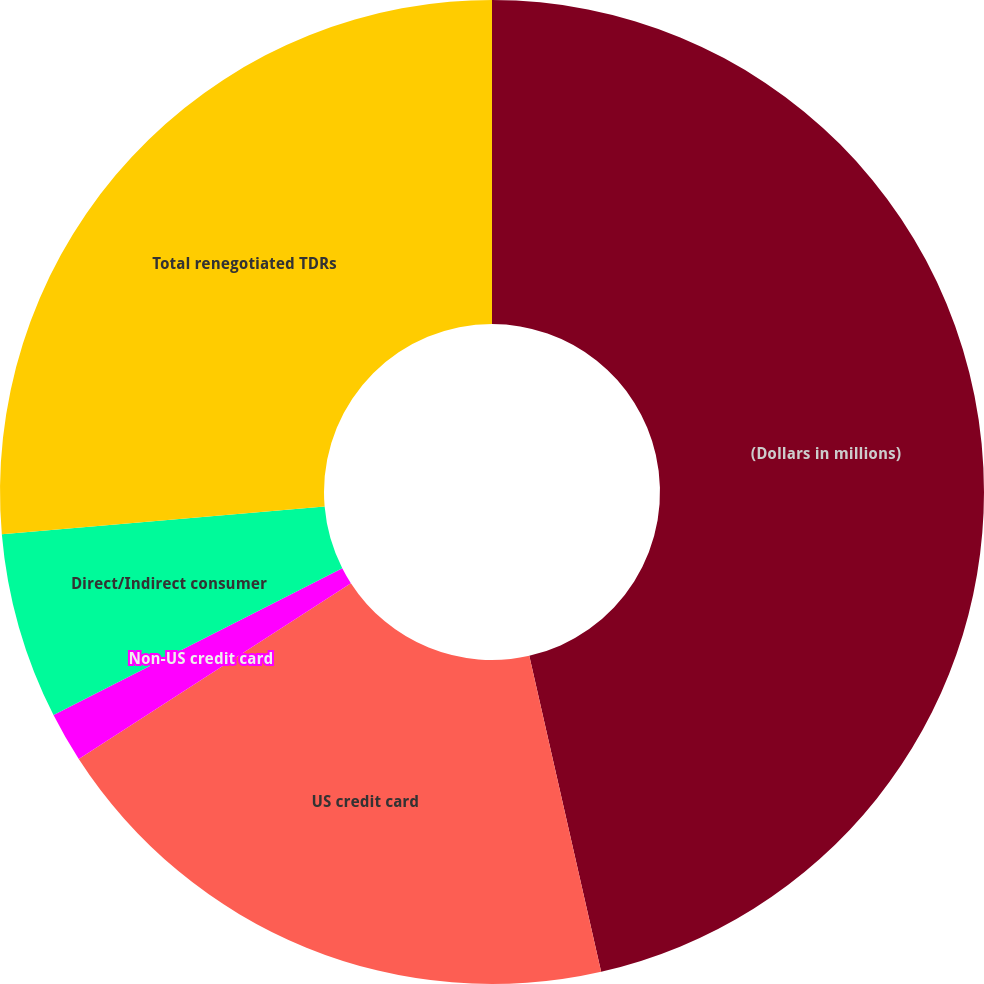Convert chart. <chart><loc_0><loc_0><loc_500><loc_500><pie_chart><fcel>(Dollars in millions)<fcel>US credit card<fcel>Non-US credit card<fcel>Direct/Indirect consumer<fcel>Total renegotiated TDRs<nl><fcel>46.44%<fcel>19.43%<fcel>1.64%<fcel>6.12%<fcel>26.37%<nl></chart> 